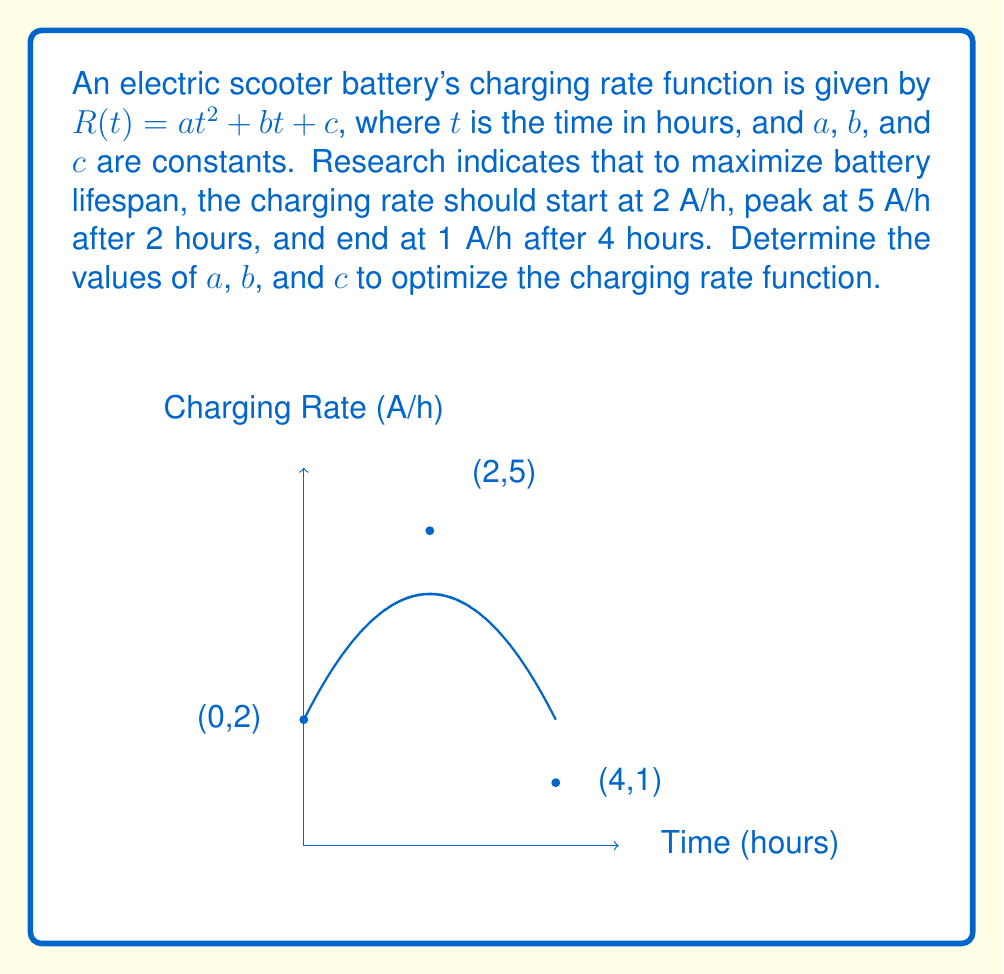Give your solution to this math problem. To solve this problem, we'll use the given information to set up a system of equations:

1) At $t=0$, $R(0) = 2$:
   $$ c = 2 $$

2) At $t=2$, $R(2) = 5$:
   $$ 4a + 2b + 2 = 5 $$

3) At $t=4$, $R(4) = 1$:
   $$ 16a + 4b + 2 = 1 $$

4) To find the peak at $t=2$, we use the derivative:
   $$ R'(t) = 2at + b $$
   At $t=2$, $R'(2) = 0$:
   $$ 4a + b = 0 $$

Now we have a system of four equations:
1) $c = 2$
2) $4a + 2b = 3$
3) $16a + 4b = -1$
4) $4a + b = 0$

Solving this system:
- From equation 4: $b = -4a$
- Substituting into equation 2: $4a + 2(-4a) = 3$, simplifies to $-4a = 3$, so $a = -0.75$
- Then $b = -4(-0.75) = 3$
- We already know $c = 2$

Therefore, the optimal charging rate function is:
$$ R(t) = -0.75t^2 + 3t + 2 $$
Answer: $R(t) = -0.75t^2 + 3t + 2$ 